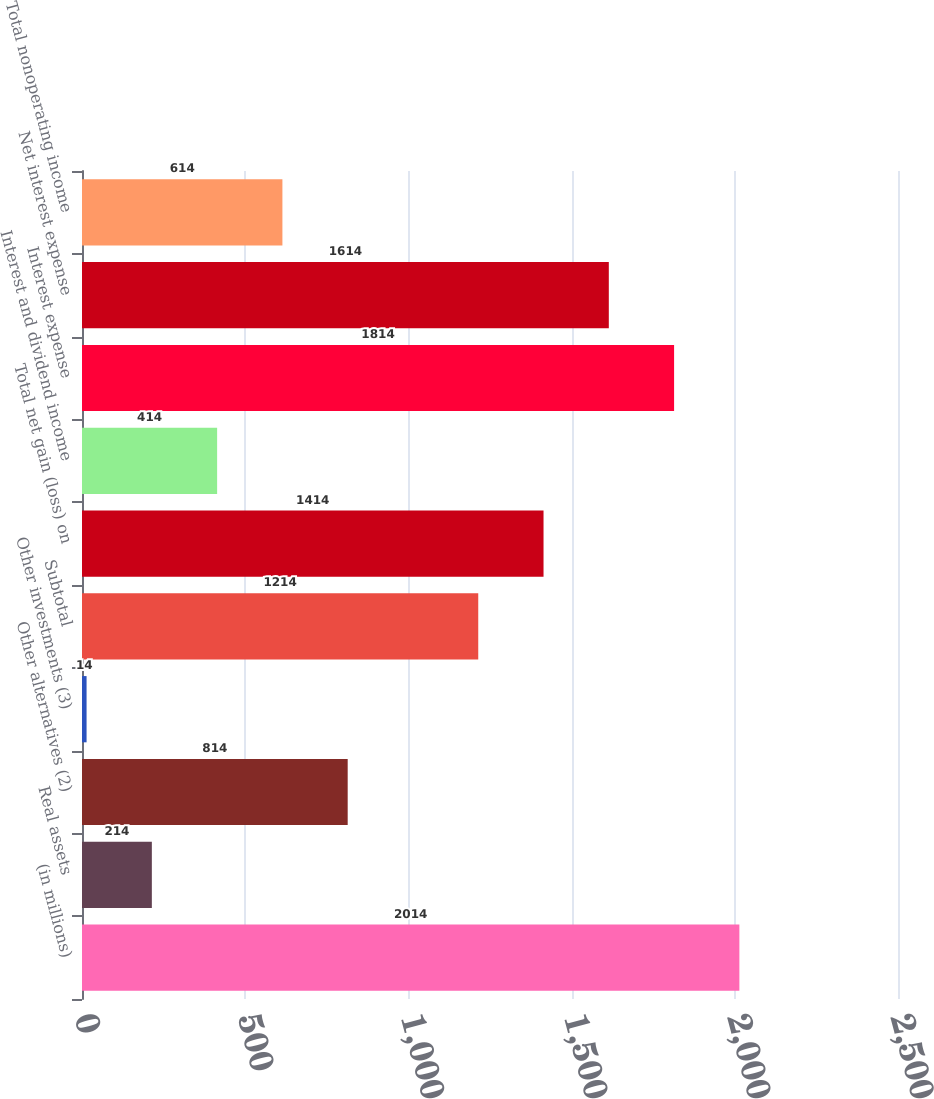<chart> <loc_0><loc_0><loc_500><loc_500><bar_chart><fcel>(in millions)<fcel>Real assets<fcel>Other alternatives (2)<fcel>Other investments (3)<fcel>Subtotal<fcel>Total net gain (loss) on<fcel>Interest and dividend income<fcel>Interest expense<fcel>Net interest expense<fcel>Total nonoperating income<nl><fcel>2014<fcel>214<fcel>814<fcel>14<fcel>1214<fcel>1414<fcel>414<fcel>1814<fcel>1614<fcel>614<nl></chart> 